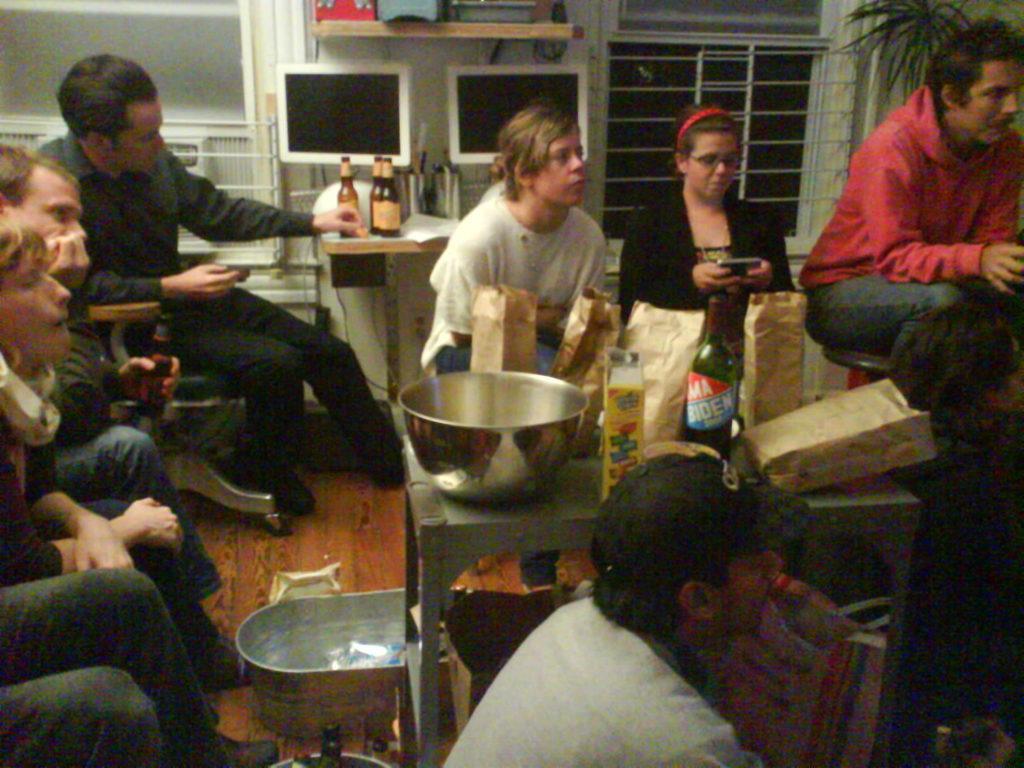How would you summarize this image in a sentence or two? This picture describes about group of people they are all seated on the chair, in front of them we can see couple of bags, a bowl, bottles on the table, in the background we can see a plant, curtains and couple of monitors. 